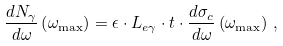<formula> <loc_0><loc_0><loc_500><loc_500>\frac { d N _ { \gamma } } { d \omega } \left ( \omega _ { \max } \right ) = \epsilon \cdot L _ { e \gamma } \cdot t \cdot \frac { d \sigma _ { c } } { d \omega } \left ( \omega _ { \max } \right ) \, ,</formula> 